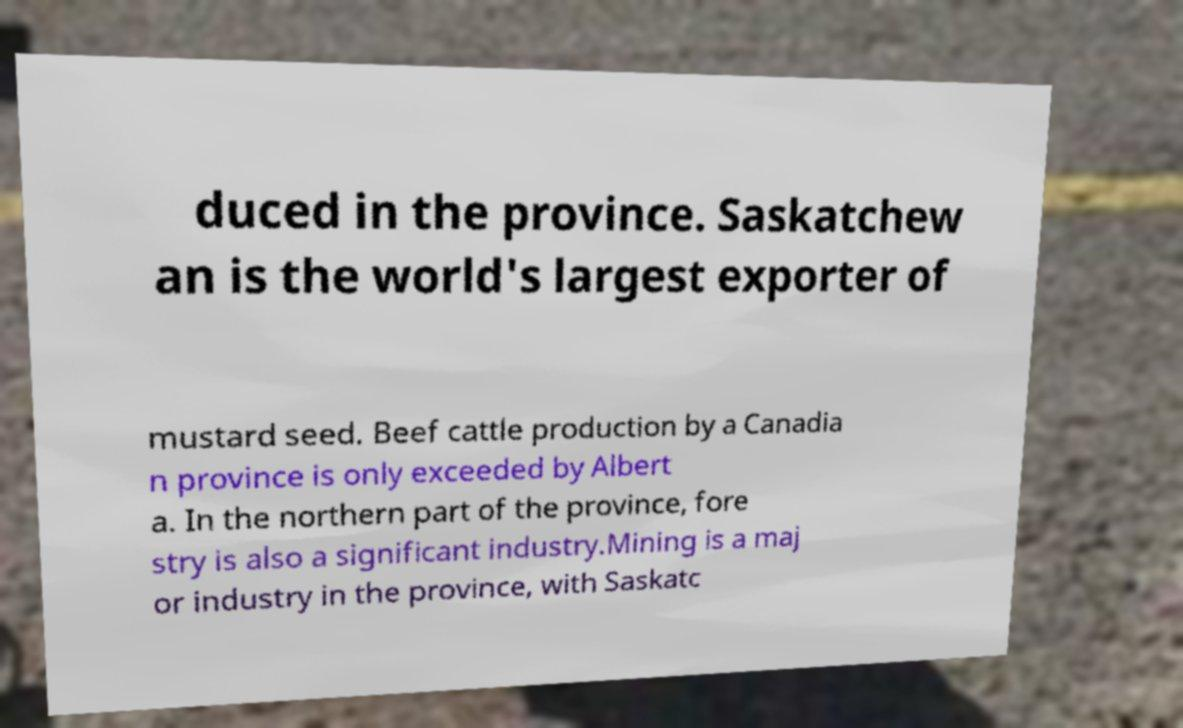Can you accurately transcribe the text from the provided image for me? duced in the province. Saskatchew an is the world's largest exporter of mustard seed. Beef cattle production by a Canadia n province is only exceeded by Albert a. In the northern part of the province, fore stry is also a significant industry.Mining is a maj or industry in the province, with Saskatc 